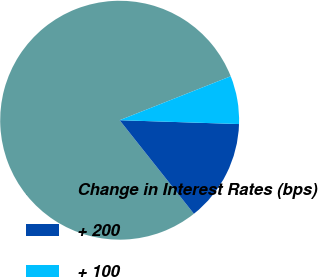<chart> <loc_0><loc_0><loc_500><loc_500><pie_chart><fcel>Change in Interest Rates (bps)<fcel>+ 200<fcel>+ 100<nl><fcel>79.68%<fcel>13.81%<fcel>6.51%<nl></chart> 